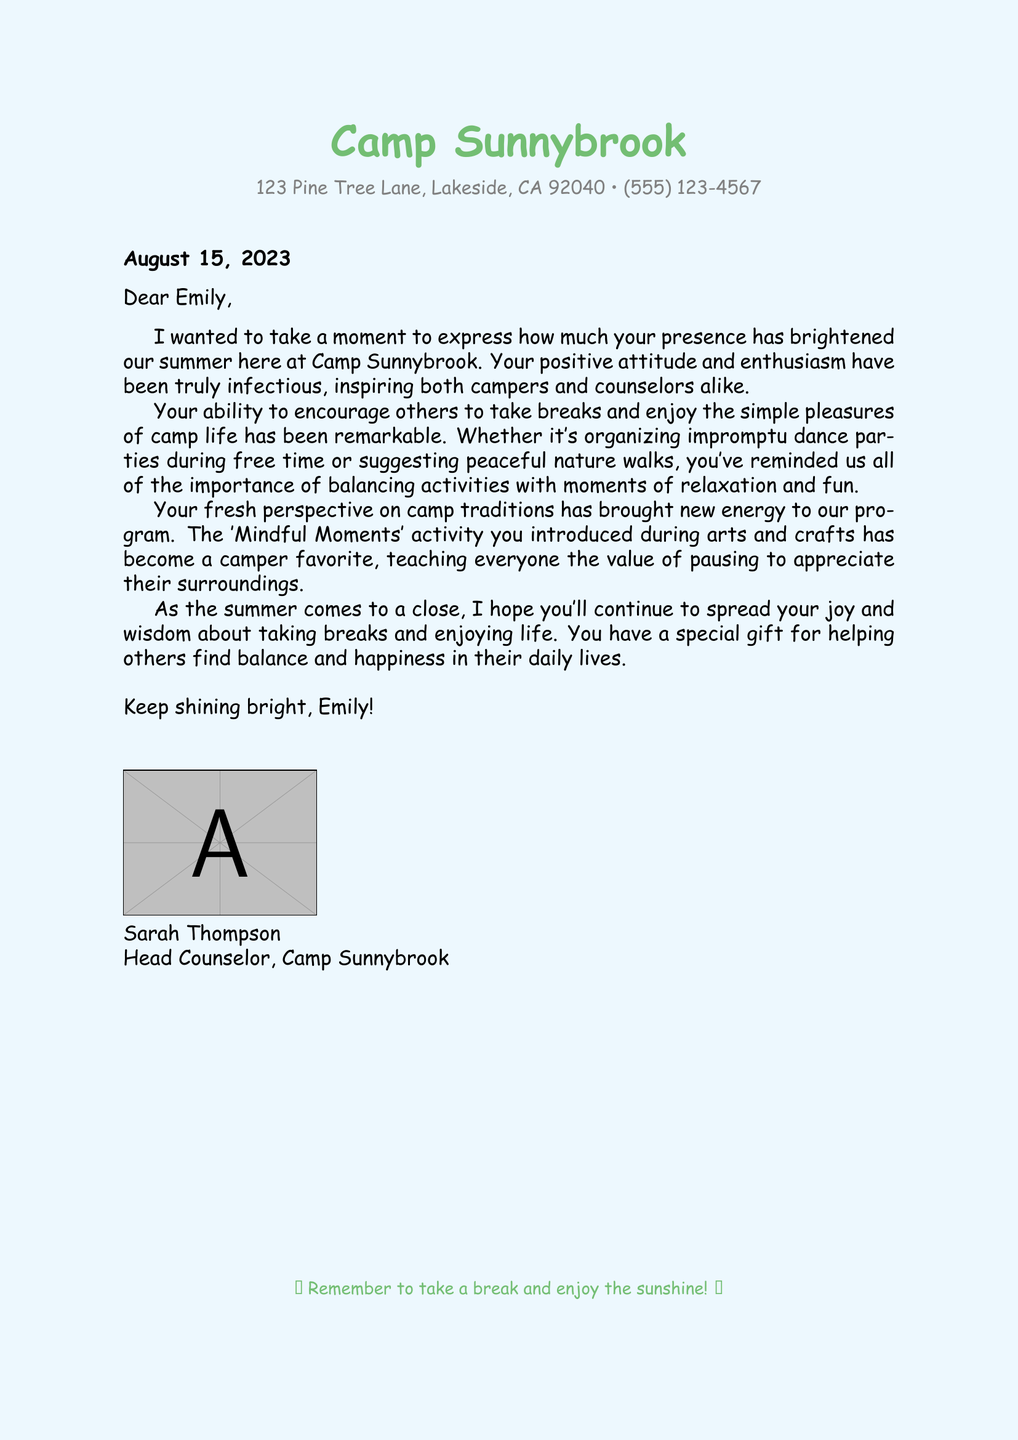What is the name of the camp? The name of the camp is mentioned in the header of the document.
Answer: Camp Sunnybrook Who wrote the note? The head counselor Sarah Thompson signed the note, indicating authorship.
Answer: Sarah Thompson What date is the note addressed? The document states the date right after the address.
Answer: August 15, 2023 What activity did Emily introduce? The note references a specific activity that Emily introduced to the campers.
Answer: Mindful Moments What is one way Emily encouraged breaks? The document lists a couple of activities that Emily suggested for breaks.
Answer: Nature walks Which two things did Emily inspire among campers and counselors? The note mentions how Emily's presence affected both groups positively.
Answer: Positive attitude and enthusiasm Where is Camp Sunnybrook located? The address provided in the document specifies the location of the camp.
Answer: 123 Pine Tree Lane, Lakeside, CA 92040 What did Sarah hope Emily would continue to do? The ending of the note expresses Sarah's hope about Emily's future actions.
Answer: Spread joy and wisdom 